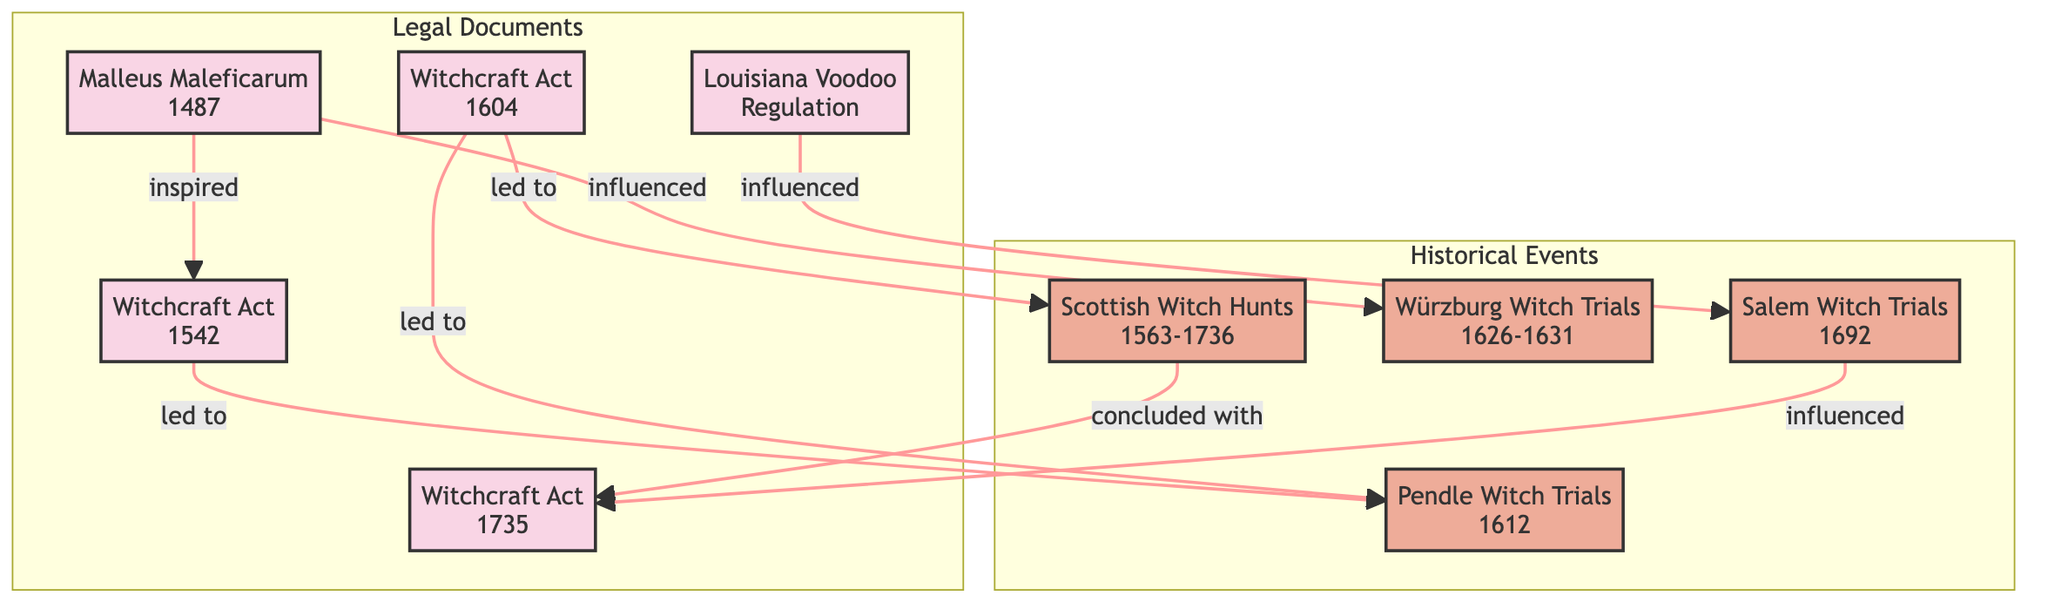What is the earliest legal document in the diagram? The diagram shows several legal documents, and by looking at the nodes, "Malleus Maleficarum (1487)" is the earliest one listed.
Answer: Malleus Maleficarum (1487) Which historical event is influenced by the "Louisiana Voodoo Regulation"? According to the links, "Louisiana Voodoo Regulation" points to "Salem Witch Trials," indicating it has an influence on that event.
Answer: Salem Witch Trials How many relationships are shown in the diagram? By counting the links between nodes, there are a total of 8 relationships represented in the diagram, connecting both legal documents and historical events.
Answer: 8 Which two acts were led to by the "Witchcraft Act of 1604"? The diagram shows that "Witchcraft Act of 1604" leads to both the "Pendle Witch Trials" and "Scottish Witch Hunts".
Answer: Pendle Witch Trials, Scottish Witch Hunts What conclusion does the "Scottish Witch Hunts" lead to? From the diagram, "Scottish Witch Hunts" concludes with the "Witchcraft Act of 1735", indicating a regulatory ending to those hunts.
Answer: Witchcraft Act of 1735 Which historical event was influenced by the "Malleus Maleficarum"? The link indicates that "Malleus Maleficarum" has a direct influence on the "Würzburg Witch Trials," demonstrating its impact on that specific historical event.
Answer: Würzburg Witch Trials What legal document is described as having influenced the "Salem Witch Trials"? The relationships show that the "Witchcraft Act of 1735" was influenced by the "Salem Witch Trials," making that act directly related to it.
Answer: Witchcraft Act of 1735 How many legal documents are featured in the diagram? The nodes classified as legal documents include "Malleus Maleficarum," "Witchcraft Act of 1542," "Witchcraft Act of 1735," "Louisiana Voodoo Regulation," and "Witchcraft Act of 1604." Therefore, there are 5 legal documents in total.
Answer: 5 What event directly followed the "Pendle Witch Trials"? Looking at the links, the "Pendle Witch Trials" is led to by the "Witchcraft Act of 1542," indicating a sequence of events. However, no event directly follows it within the immediate diagram connections.
Answer: None 